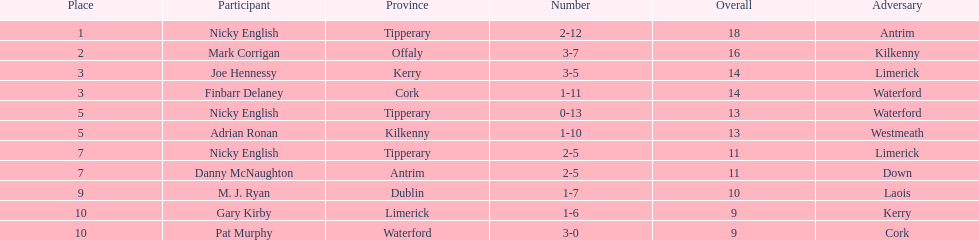If you added all the total's up, what would the number be? 138. 